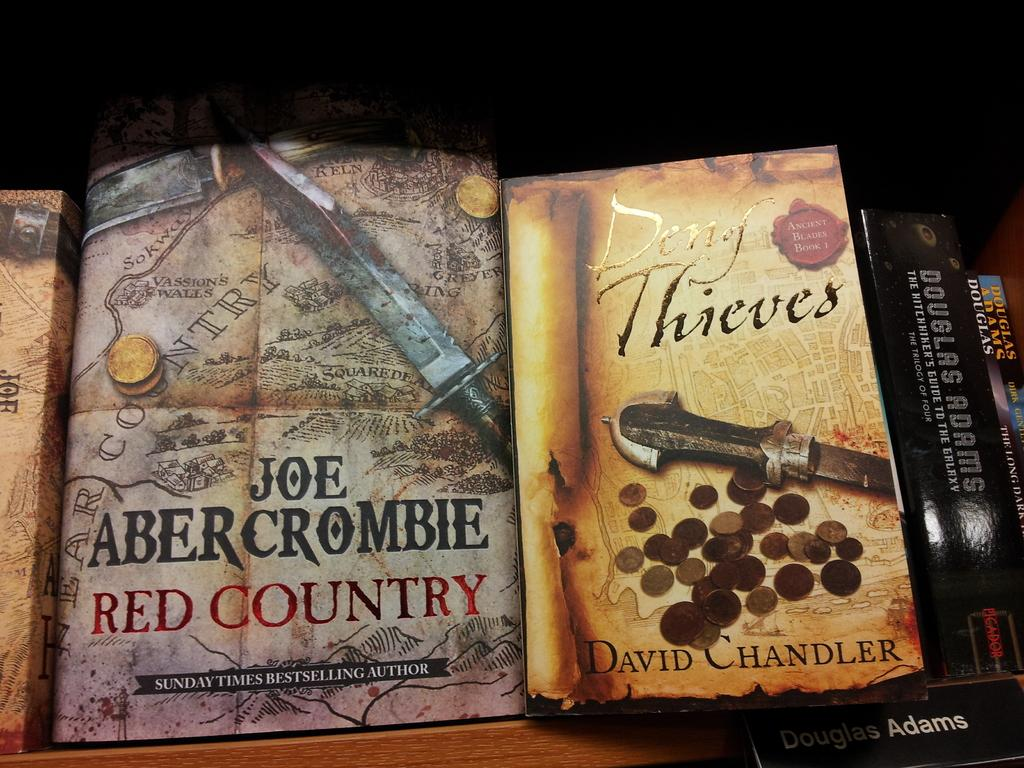<image>
Create a compact narrative representing the image presented. Books shown that are based on strategy and combat from Joe Abercrombie and Douglas Adams. 